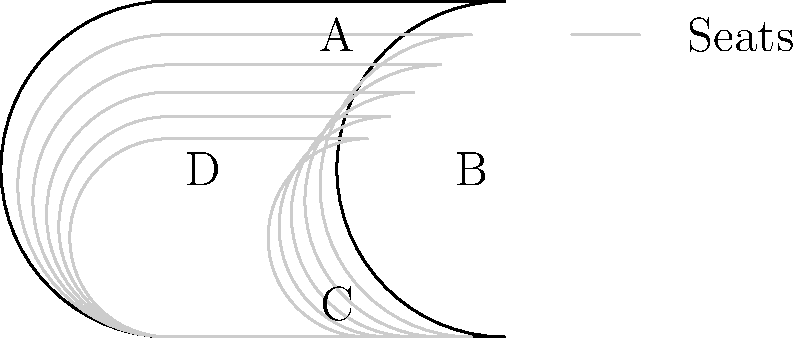As a local sports reporter covering a major wrestling event, you're tasked with estimating the crowd size. The stadium has four sections (A, B, C, and D) as shown in the bird's-eye view image. If section A can seat 5000 people, section B can seat 3000 people, and sections C and D can each seat 4000 people, what's the total seating capacity of the stadium? To estimate the total seating capacity of the stadium, we need to follow these steps:

1. Identify the seating capacity of each section:
   - Section A: 5000 people
   - Section B: 3000 people
   - Section C: 4000 people
   - Section D: 4000 people

2. Add up the seating capacities of all sections:
   $$\text{Total Capacity} = \text{Section A} + \text{Section B} + \text{Section C} + \text{Section D}$$
   $$\text{Total Capacity} = 5000 + 3000 + 4000 + 4000$$
   $$\text{Total Capacity} = 16000$$

Therefore, the total seating capacity of the stadium is 16,000 people.
Answer: 16,000 people 